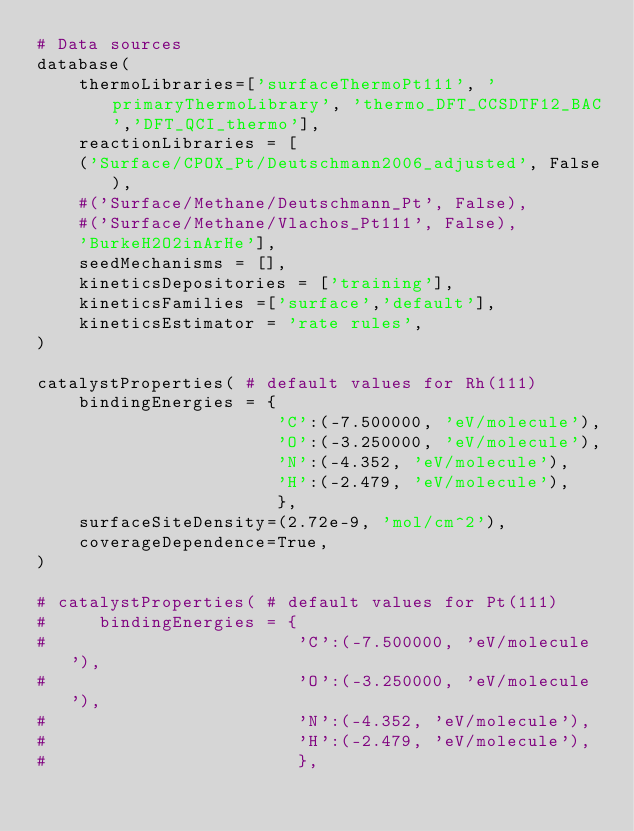<code> <loc_0><loc_0><loc_500><loc_500><_Python_># Data sources
database(
    thermoLibraries=['surfaceThermoPt111', 'primaryThermoLibrary', 'thermo_DFT_CCSDTF12_BAC','DFT_QCI_thermo'],
    reactionLibraries = [
    ('Surface/CPOX_Pt/Deutschmann2006_adjusted', False),
    #('Surface/Methane/Deutschmann_Pt', False),
    #('Surface/Methane/Vlachos_Pt111', False),
    'BurkeH2O2inArHe'],
    seedMechanisms = [],
    kineticsDepositories = ['training'],
    kineticsFamilies =['surface','default'],
    kineticsEstimator = 'rate rules',
)

catalystProperties( # default values for Rh(111)
    bindingEnergies = {
                       'C':(-7.500000, 'eV/molecule'),
                       'O':(-3.250000, 'eV/molecule'),
                       'N':(-4.352, 'eV/molecule'),
                       'H':(-2.479, 'eV/molecule'),
                       },
    surfaceSiteDensity=(2.72e-9, 'mol/cm^2'),
    coverageDependence=True,
)

# catalystProperties( # default values for Pt(111)
#     bindingEnergies = {
#                        'C':(-7.500000, 'eV/molecule'),
#                        'O':(-3.250000, 'eV/molecule'),
#                        'N':(-4.352, 'eV/molecule'),
#                        'H':(-2.479, 'eV/molecule'),
#                        },</code> 